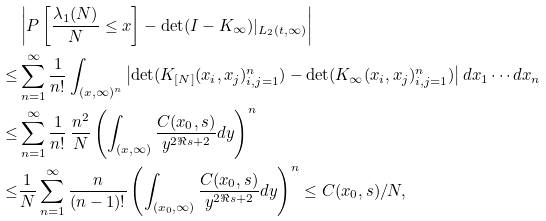Convert formula to latex. <formula><loc_0><loc_0><loc_500><loc_500>& \left | P \left [ \frac { \lambda _ { 1 } ( N ) } { N } \leq x \right ] - \det ( I - K _ { \infty } ) | _ { L _ { 2 } ( t , \infty ) } \right | \\ \leq & \sum _ { n = 1 } ^ { \infty } \frac { 1 } { n ! } \int _ { ( x , \infty ) ^ { n } } \left | \det ( K _ { [ N ] } ( x _ { i } , x _ { j } ) _ { i , j = 1 } ^ { n } ) - \det ( K _ { \infty } ( x _ { i } , x _ { j } ) _ { i , j = 1 } ^ { n } ) \right | d x _ { 1 } \cdots d x _ { n } \\ \leq & \sum _ { n = 1 } ^ { \infty } \frac { 1 } { n ! } \, \frac { n ^ { 2 } } { N } \left ( \int _ { ( x , \infty ) } \frac { C ( x _ { 0 } , s ) } { y ^ { 2 \Re { s } + 2 } } d y \right ) ^ { n } \\ \leq & \frac { 1 } { N } \sum _ { n = 1 } ^ { \infty } \frac { n } { ( n - 1 ) ! } \left ( \int _ { ( x _ { 0 } , \infty ) } \frac { C ( x _ { 0 } , s ) } { y ^ { 2 \Re { s } + 2 } } d y \right ) ^ { n } \leq C ( x _ { 0 } , s ) / N ,</formula> 